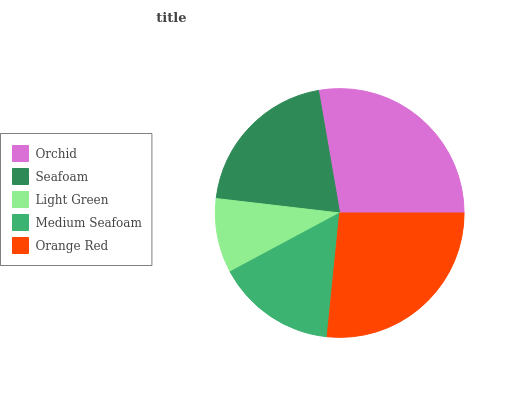Is Light Green the minimum?
Answer yes or no. Yes. Is Orchid the maximum?
Answer yes or no. Yes. Is Seafoam the minimum?
Answer yes or no. No. Is Seafoam the maximum?
Answer yes or no. No. Is Orchid greater than Seafoam?
Answer yes or no. Yes. Is Seafoam less than Orchid?
Answer yes or no. Yes. Is Seafoam greater than Orchid?
Answer yes or no. No. Is Orchid less than Seafoam?
Answer yes or no. No. Is Seafoam the high median?
Answer yes or no. Yes. Is Seafoam the low median?
Answer yes or no. Yes. Is Light Green the high median?
Answer yes or no. No. Is Light Green the low median?
Answer yes or no. No. 